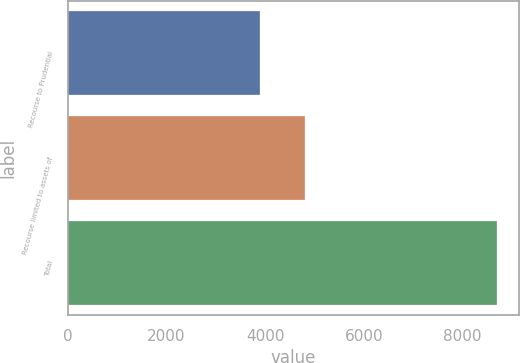Convert chart. <chart><loc_0><loc_0><loc_500><loc_500><bar_chart><fcel>Recourse to Prudential<fcel>Recourse limited to assets of<fcel>Total<nl><fcel>3897<fcel>4810<fcel>8707<nl></chart> 